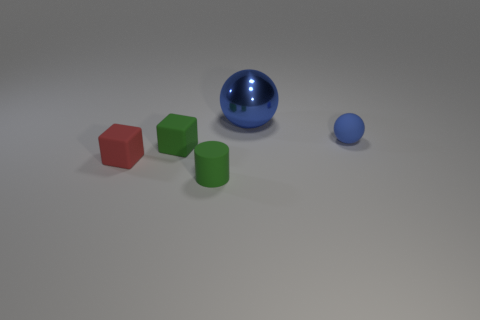Add 4 small rubber spheres. How many objects exist? 9 Subtract all blocks. How many objects are left? 3 Add 1 big green rubber balls. How many big green rubber balls exist? 1 Subtract 1 green blocks. How many objects are left? 4 Subtract all large blue things. Subtract all large blue balls. How many objects are left? 3 Add 3 blue metal things. How many blue metal things are left? 4 